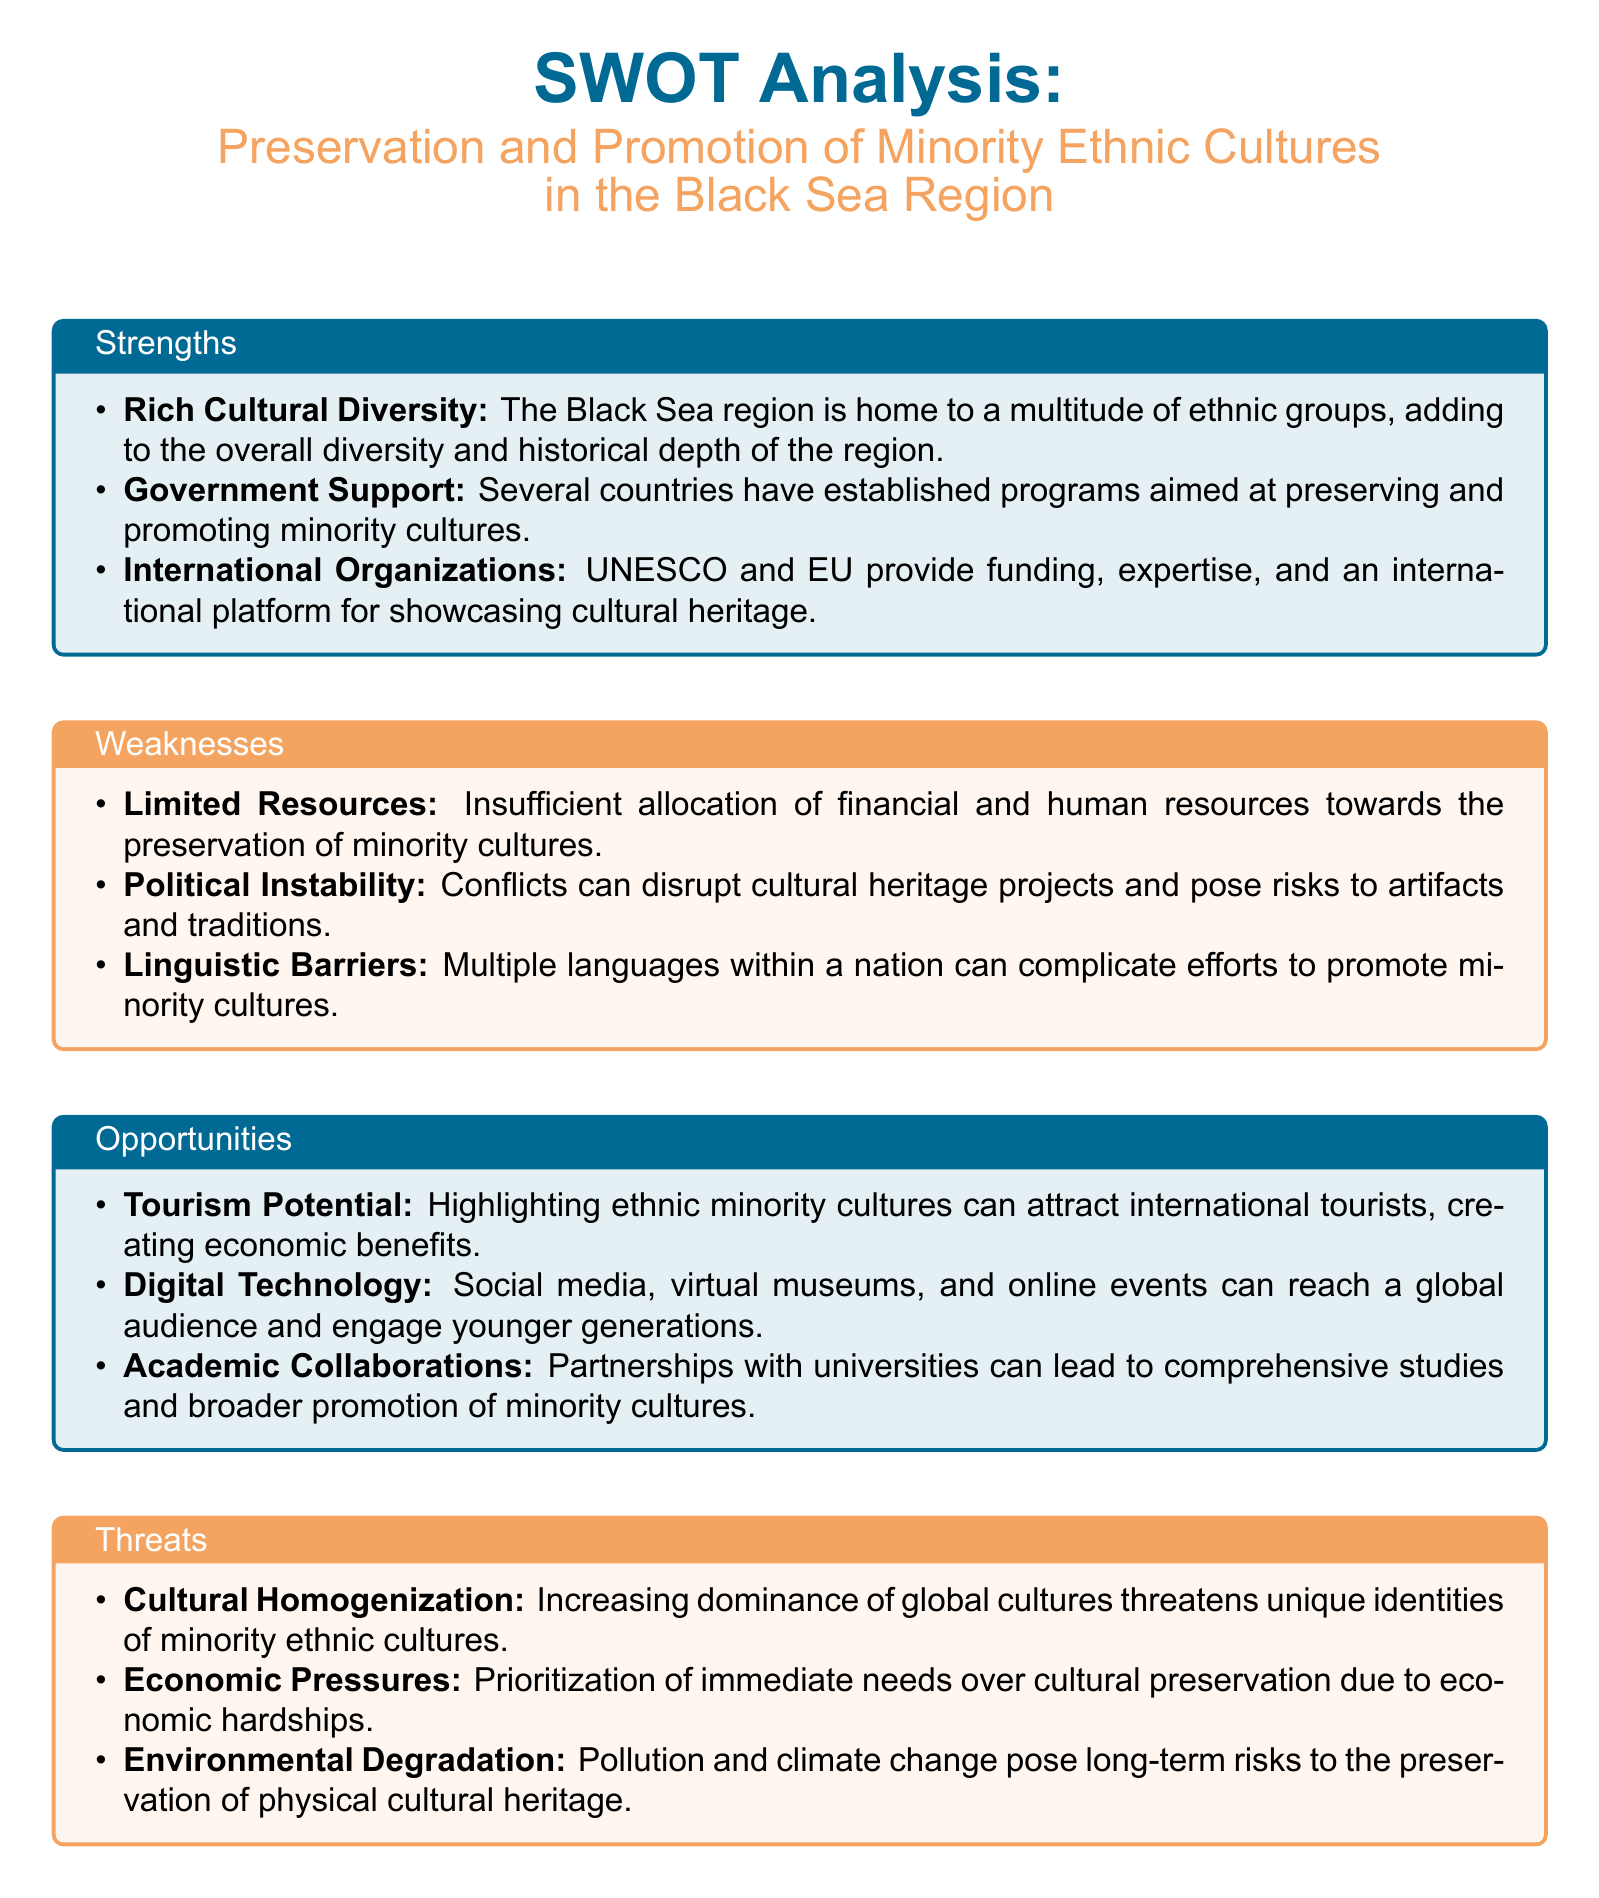What is one strength of the Black Sea region? The document lists multiple strengths, one of which is the rich cultural diversity found in the region.
Answer: Rich Cultural Diversity What is a weakness related to resources? The document mentions that insufficient allocation of financial and human resources is a weakness affecting cultural preservation.
Answer: Limited Resources Name one opportunity related to technology. The document states that social media and online events can help in engaging audiences, identifying digital technology as an opportunity.
Answer: Digital Technology What threat involves global cultures? The document identifies cultural homogenization as a threat to the unique identities of minority ethnic cultures.
Answer: Cultural Homogenization Which organization provides funding for cultural heritage? The document mentions UNESCO as one of the international organizations that provide support for minority cultures.
Answer: UNESCO What can attract international tourists in the Black Sea region? The document suggests that highlighting ethnic minority cultures can serve as an attraction for international tourists.
Answer: Tourism Potential What is a consequence of political instability on cultural projects? The document states that conflicts can disrupt cultural heritage projects, indicating that political instability poses risks.
Answer: Disruption of projects Which collaboration can promote minority cultures? The document mentions partnerships with universities as a means to foster promotion of minority cultures.
Answer: Academic Collaborations What economic challenge is cited in the document? The document points out that economic hardships lead to prioritization of immediate needs over cultural preservation.
Answer: Economic Pressures 